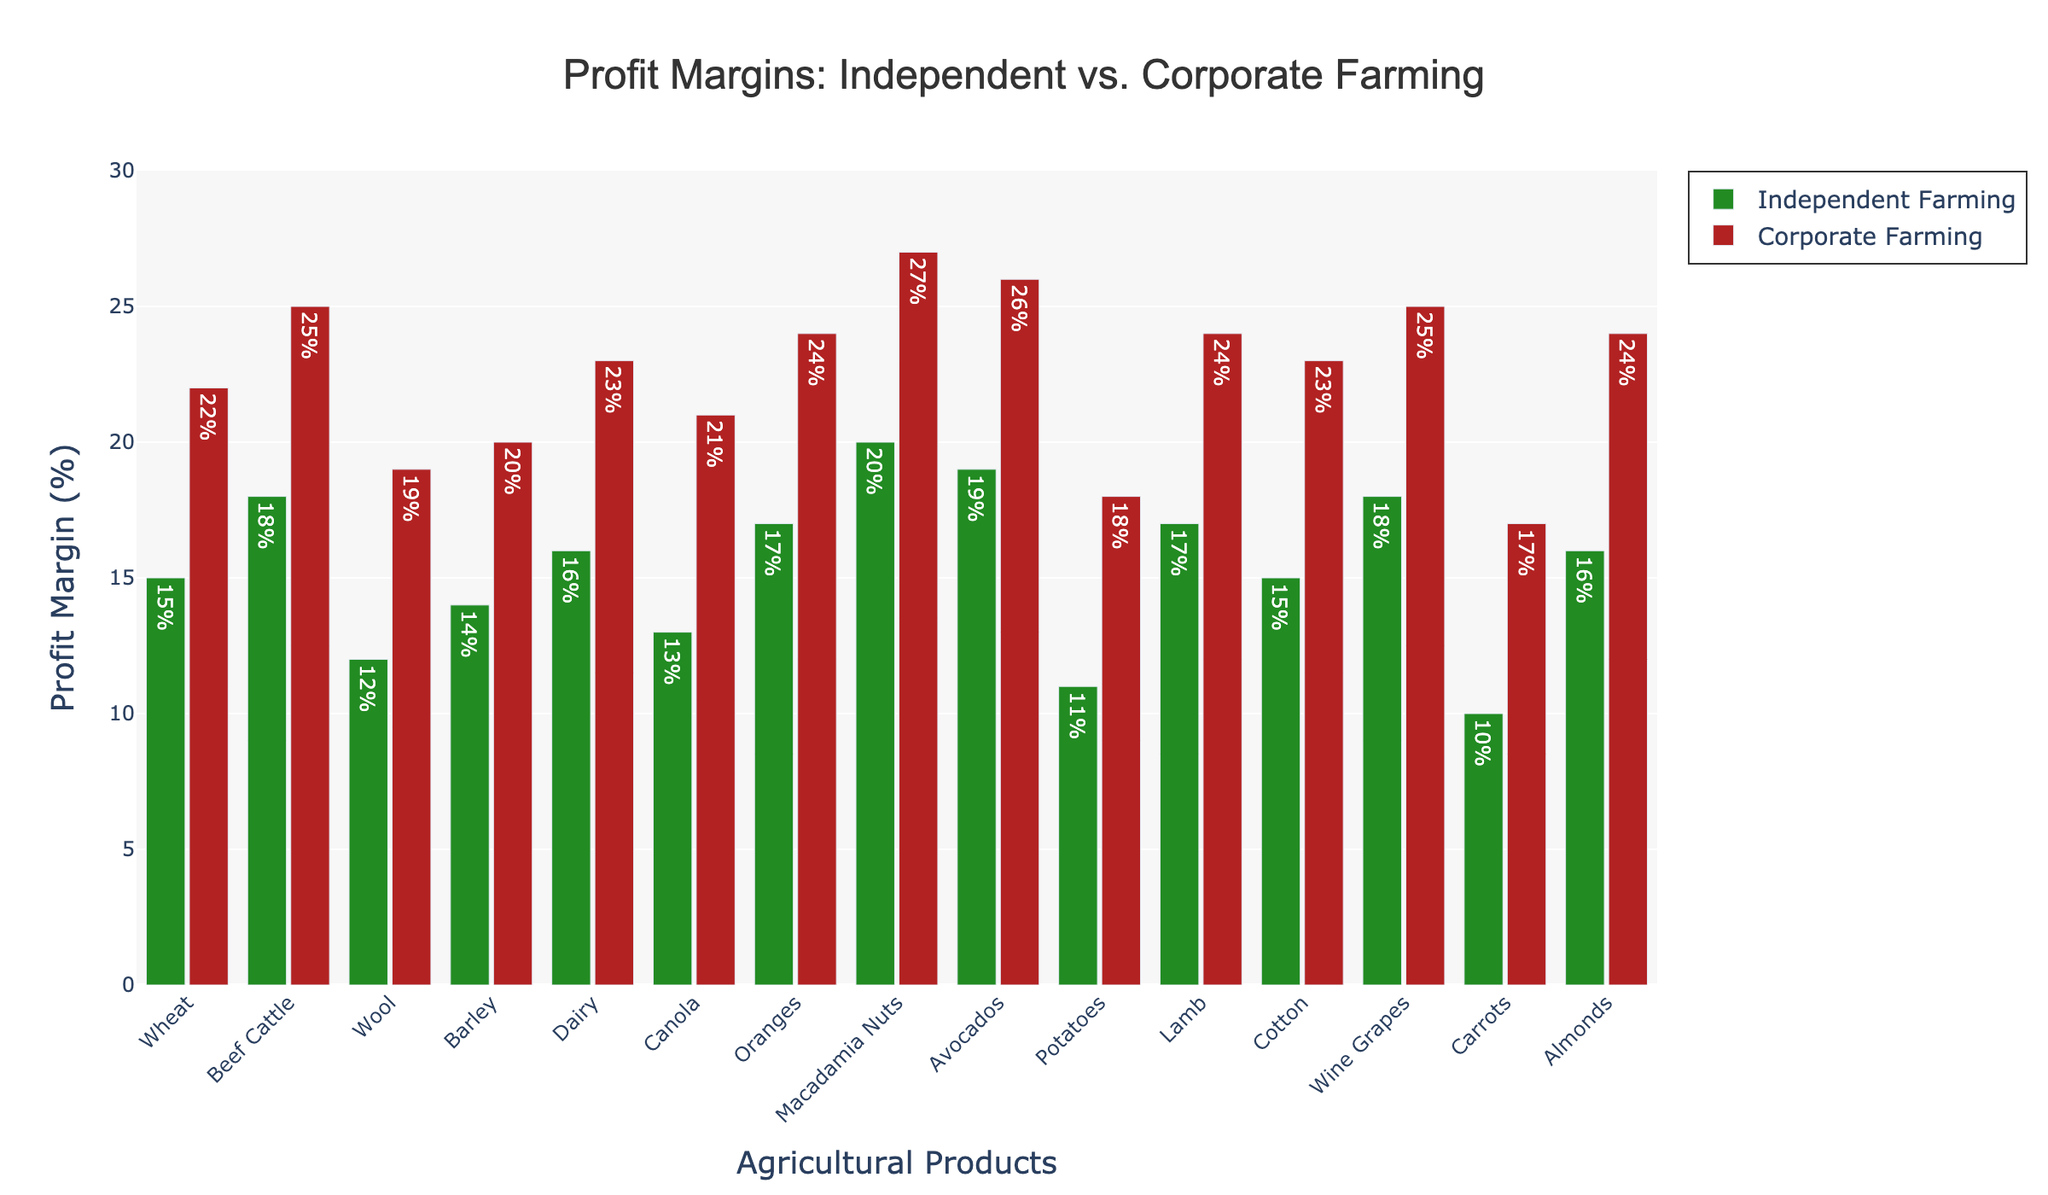Which agricultural product has the highest profit margin in independent farming? By looking at the highest green bar among the products, we can see that Macadamia Nuts have the highest profit margin in independent farming.
Answer: Macadamia Nuts What is the difference in profit margin between corporate farming and independent farming for Dairy? We need to subtract the independent farming profit margin for Dairy from the corporate farming profit margin for Dairy. It is 23% - 16% = 7%.
Answer: 7% Which product shows the smallest difference in profit margins between independent and corporate farming? Comparing the differences for each product, Potatoes have the smallest difference, which is 18% - 11% = 7%.
Answer: Potatoes What is the average profit margin for corporate farming across all products? Sum the corporate farming percentages and divide by the number of products. The sum is 303% and there are 15 products. So, 303% / 15 ≈ 20.2%.
Answer: 20.2% Which product has the closest profit margins between corporate and independent farming? By looking at the smallest gaps between red and green bars among all products, Potatoes have the closest profit margins of 18% (corporate) and 11% (independent).
Answer: Potatoes How much higher is the profit margin for corporate farming compared to independent farming for Beef Cattle? The difference in profit margin is found by subtracting the independent farming margin from the corporate farming margin for Beef Cattle: 25% - 18% = 7%.
Answer: 7% Is there any product where the profit margin exceeds 25% in independent farming? By examining the green bars, none of the independent farming profit margins exceed 25%.
Answer: No What is the total profit margin difference for all products between corporate and independent farming? Sum all the differences for each product between corporate and independent farming: (22-15) + (25-18) + (19-12) + (20-14) + (23-16) + (21-13) + (24-17) + (27-20) + (26-19) + (18-11) + (24-17) + (23-15) + (25-18) + (17-10) + (24-16) = 96%.
Answer: 96% What is the percentage increase in profit margin for Wine Grapes from independent to corporate farming? Divide the difference in profit margins by the independent margin and multiply by 100: ((25% - 18%) / 18%) * 100 ≈ 38.89%.
Answer: 38.89% Which product stands out as having the highest corporate farming profit margin? The red bar that reaches the highest among all products shows that Macadamia Nuts have the highest corporate farming profit margin at 27%.
Answer: Macadamia Nuts 